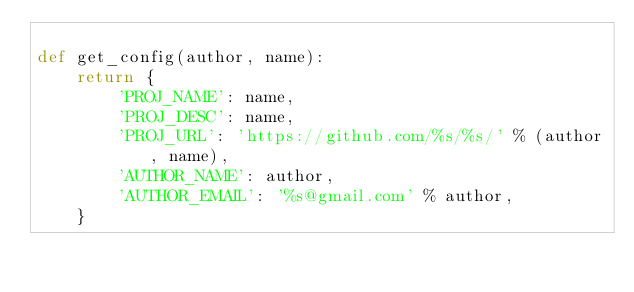Convert code to text. <code><loc_0><loc_0><loc_500><loc_500><_Python_>
def get_config(author, name):
    return {
        'PROJ_NAME': name,
        'PROJ_DESC': name,
        'PROJ_URL': 'https://github.com/%s/%s/' % (author, name),
        'AUTHOR_NAME': author,
        'AUTHOR_EMAIL': '%s@gmail.com' % author,
    }
</code> 